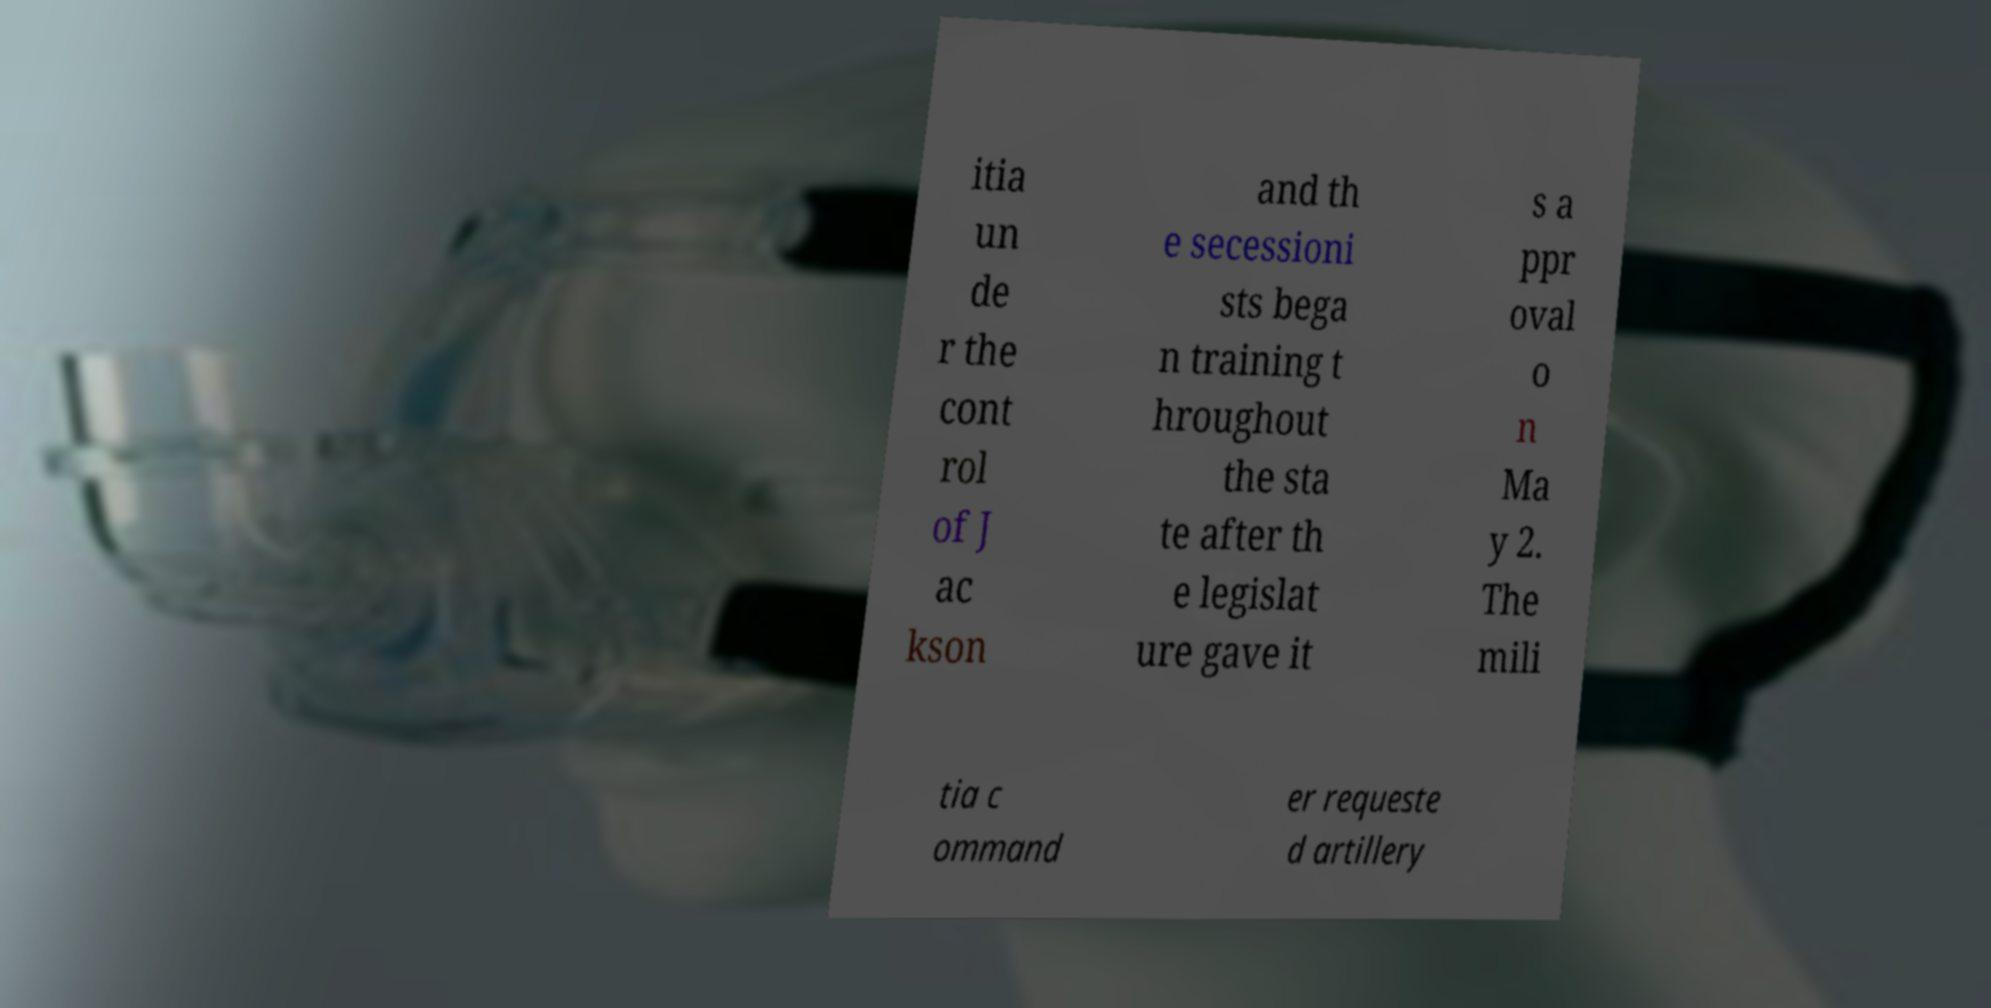What messages or text are displayed in this image? I need them in a readable, typed format. itia un de r the cont rol of J ac kson and th e secessioni sts bega n training t hroughout the sta te after th e legislat ure gave it s a ppr oval o n Ma y 2. The mili tia c ommand er requeste d artillery 